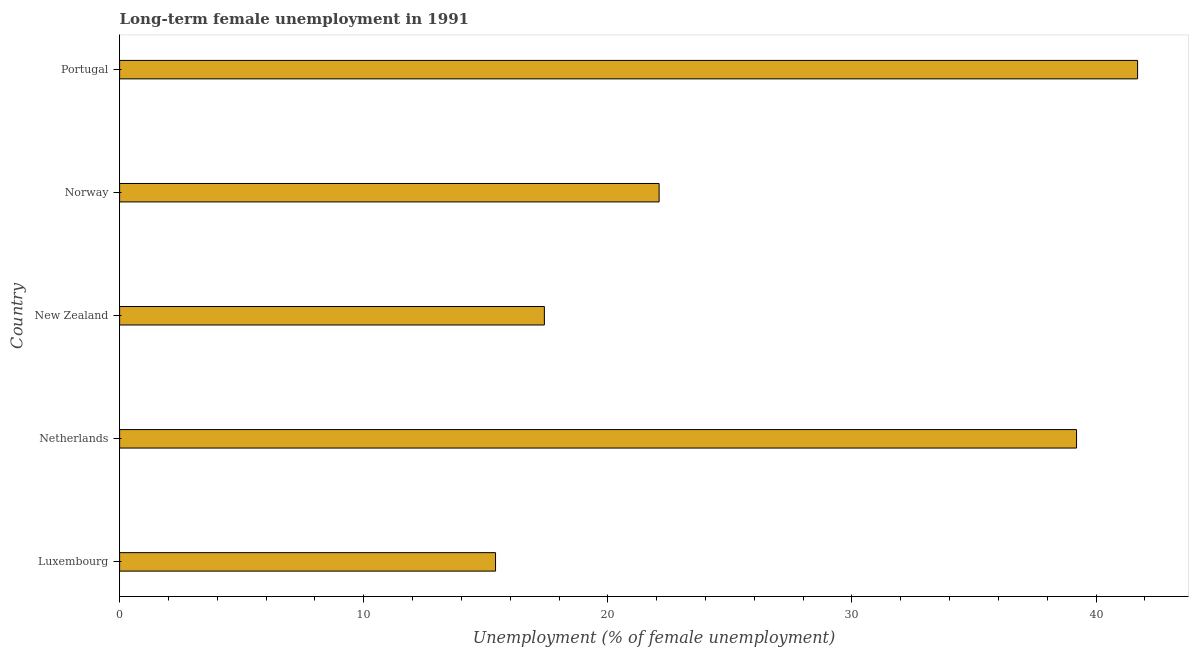Does the graph contain any zero values?
Your response must be concise. No. Does the graph contain grids?
Your response must be concise. No. What is the title of the graph?
Provide a succinct answer. Long-term female unemployment in 1991. What is the label or title of the X-axis?
Offer a very short reply. Unemployment (% of female unemployment). What is the long-term female unemployment in Norway?
Offer a very short reply. 22.1. Across all countries, what is the maximum long-term female unemployment?
Provide a succinct answer. 41.7. Across all countries, what is the minimum long-term female unemployment?
Provide a succinct answer. 15.4. In which country was the long-term female unemployment maximum?
Keep it short and to the point. Portugal. In which country was the long-term female unemployment minimum?
Keep it short and to the point. Luxembourg. What is the sum of the long-term female unemployment?
Provide a short and direct response. 135.8. What is the difference between the long-term female unemployment in Netherlands and New Zealand?
Your response must be concise. 21.8. What is the average long-term female unemployment per country?
Offer a terse response. 27.16. What is the median long-term female unemployment?
Provide a short and direct response. 22.1. In how many countries, is the long-term female unemployment greater than 12 %?
Keep it short and to the point. 5. What is the ratio of the long-term female unemployment in Norway to that in Portugal?
Keep it short and to the point. 0.53. Is the difference between the long-term female unemployment in Netherlands and Norway greater than the difference between any two countries?
Give a very brief answer. No. What is the difference between the highest and the second highest long-term female unemployment?
Ensure brevity in your answer.  2.5. What is the difference between the highest and the lowest long-term female unemployment?
Make the answer very short. 26.3. How many bars are there?
Provide a succinct answer. 5. How many countries are there in the graph?
Keep it short and to the point. 5. What is the difference between two consecutive major ticks on the X-axis?
Offer a terse response. 10. What is the Unemployment (% of female unemployment) in Luxembourg?
Your answer should be compact. 15.4. What is the Unemployment (% of female unemployment) in Netherlands?
Make the answer very short. 39.2. What is the Unemployment (% of female unemployment) in New Zealand?
Your answer should be very brief. 17.4. What is the Unemployment (% of female unemployment) of Norway?
Keep it short and to the point. 22.1. What is the Unemployment (% of female unemployment) of Portugal?
Give a very brief answer. 41.7. What is the difference between the Unemployment (% of female unemployment) in Luxembourg and Netherlands?
Your answer should be very brief. -23.8. What is the difference between the Unemployment (% of female unemployment) in Luxembourg and New Zealand?
Your response must be concise. -2. What is the difference between the Unemployment (% of female unemployment) in Luxembourg and Norway?
Your answer should be very brief. -6.7. What is the difference between the Unemployment (% of female unemployment) in Luxembourg and Portugal?
Your response must be concise. -26.3. What is the difference between the Unemployment (% of female unemployment) in Netherlands and New Zealand?
Offer a very short reply. 21.8. What is the difference between the Unemployment (% of female unemployment) in Netherlands and Portugal?
Offer a terse response. -2.5. What is the difference between the Unemployment (% of female unemployment) in New Zealand and Norway?
Keep it short and to the point. -4.7. What is the difference between the Unemployment (% of female unemployment) in New Zealand and Portugal?
Provide a short and direct response. -24.3. What is the difference between the Unemployment (% of female unemployment) in Norway and Portugal?
Give a very brief answer. -19.6. What is the ratio of the Unemployment (% of female unemployment) in Luxembourg to that in Netherlands?
Offer a very short reply. 0.39. What is the ratio of the Unemployment (% of female unemployment) in Luxembourg to that in New Zealand?
Provide a short and direct response. 0.89. What is the ratio of the Unemployment (% of female unemployment) in Luxembourg to that in Norway?
Provide a short and direct response. 0.7. What is the ratio of the Unemployment (% of female unemployment) in Luxembourg to that in Portugal?
Provide a short and direct response. 0.37. What is the ratio of the Unemployment (% of female unemployment) in Netherlands to that in New Zealand?
Provide a succinct answer. 2.25. What is the ratio of the Unemployment (% of female unemployment) in Netherlands to that in Norway?
Make the answer very short. 1.77. What is the ratio of the Unemployment (% of female unemployment) in Netherlands to that in Portugal?
Your response must be concise. 0.94. What is the ratio of the Unemployment (% of female unemployment) in New Zealand to that in Norway?
Make the answer very short. 0.79. What is the ratio of the Unemployment (% of female unemployment) in New Zealand to that in Portugal?
Your response must be concise. 0.42. What is the ratio of the Unemployment (% of female unemployment) in Norway to that in Portugal?
Provide a short and direct response. 0.53. 